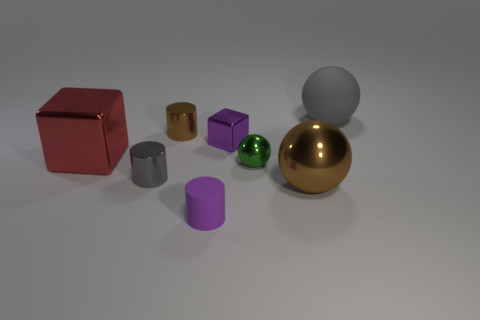Subtract all rubber cylinders. How many cylinders are left? 2 Add 1 tiny green shiny cubes. How many objects exist? 9 Subtract all purple cylinders. How many cylinders are left? 2 Subtract 1 purple cubes. How many objects are left? 7 Subtract all cylinders. How many objects are left? 5 Subtract 2 balls. How many balls are left? 1 Subtract all cyan blocks. Subtract all cyan cylinders. How many blocks are left? 2 Subtract all small gray matte cylinders. Subtract all gray matte objects. How many objects are left? 7 Add 3 red blocks. How many red blocks are left? 4 Add 6 green metallic things. How many green metallic things exist? 7 